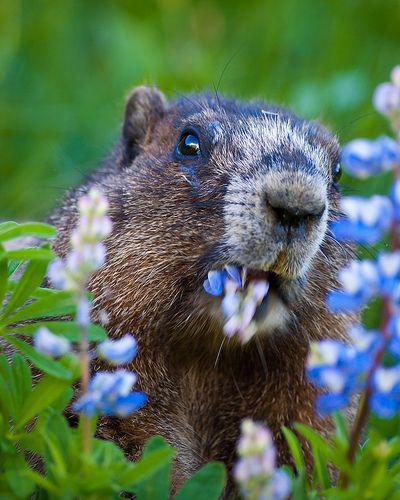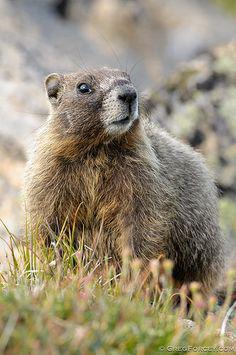The first image is the image on the left, the second image is the image on the right. Examine the images to the left and right. Is the description "At least two animals are on a rocky surface." accurate? Answer yes or no. No. The first image is the image on the left, the second image is the image on the right. Evaluate the accuracy of this statement regarding the images: "Each image contains just one marmot, and marmots on the right and left have similar style poses with some paws visible.". Is it true? Answer yes or no. No. 